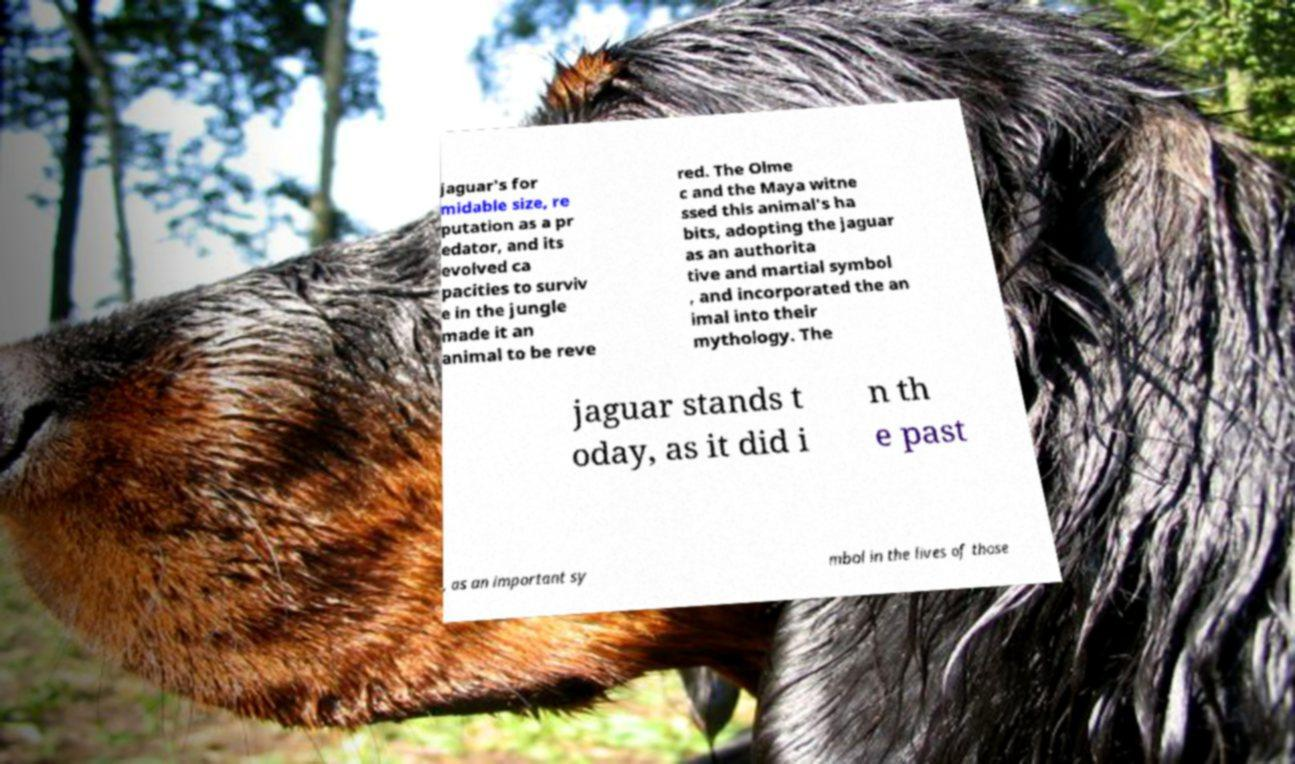Could you extract and type out the text from this image? jaguar's for midable size, re putation as a pr edator, and its evolved ca pacities to surviv e in the jungle made it an animal to be reve red. The Olme c and the Maya witne ssed this animal's ha bits, adopting the jaguar as an authorita tive and martial symbol , and incorporated the an imal into their mythology. The jaguar stands t oday, as it did i n th e past , as an important sy mbol in the lives of those 